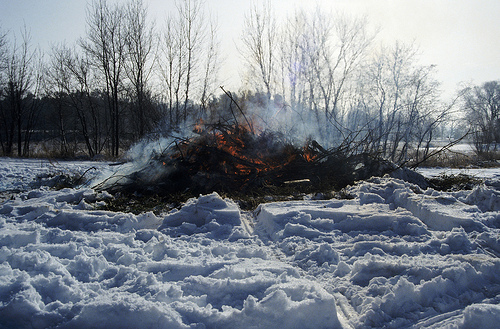<image>
Is there a fire on the snow? Yes. Looking at the image, I can see the fire is positioned on top of the snow, with the snow providing support. Is the tree next to the sky? No. The tree is not positioned next to the sky. They are located in different areas of the scene. 